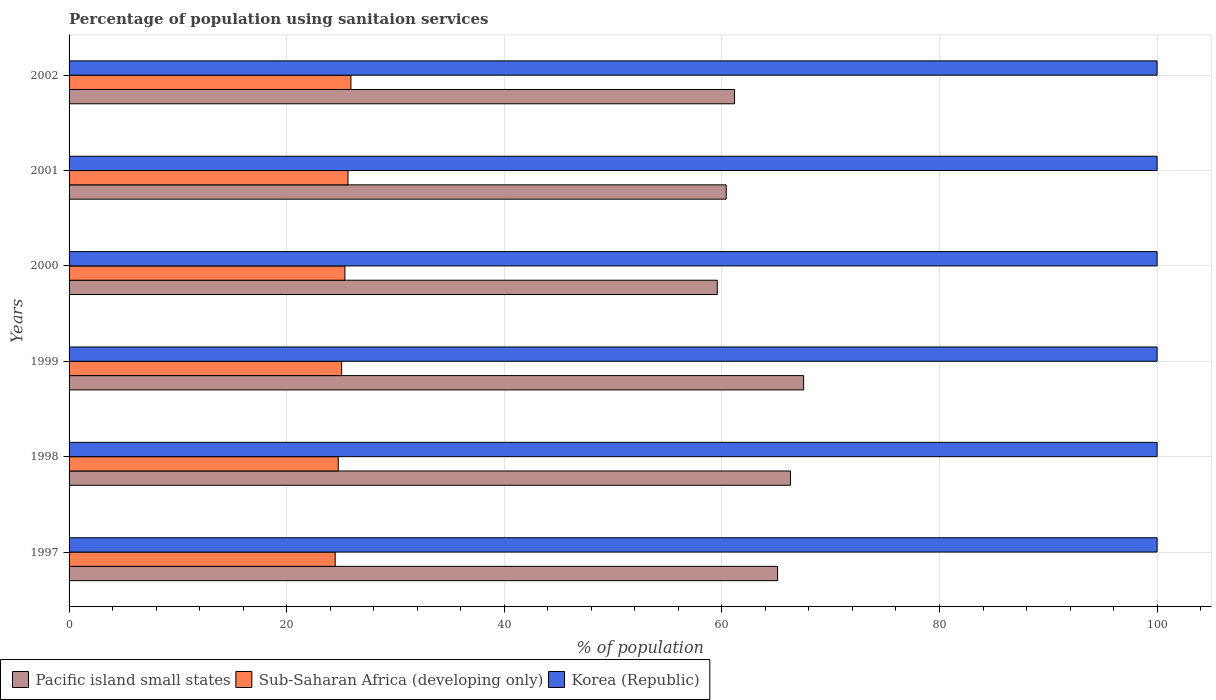How many groups of bars are there?
Ensure brevity in your answer.  6. Are the number of bars per tick equal to the number of legend labels?
Provide a succinct answer. Yes. How many bars are there on the 2nd tick from the top?
Ensure brevity in your answer.  3. How many bars are there on the 1st tick from the bottom?
Your answer should be very brief. 3. In how many cases, is the number of bars for a given year not equal to the number of legend labels?
Give a very brief answer. 0. What is the percentage of population using sanitaion services in Korea (Republic) in 1998?
Your answer should be compact. 100. Across all years, what is the maximum percentage of population using sanitaion services in Sub-Saharan Africa (developing only)?
Make the answer very short. 25.91. Across all years, what is the minimum percentage of population using sanitaion services in Pacific island small states?
Make the answer very short. 59.58. What is the total percentage of population using sanitaion services in Pacific island small states in the graph?
Provide a short and direct response. 380.07. What is the difference between the percentage of population using sanitaion services in Korea (Republic) in 1998 and that in 2000?
Offer a very short reply. 0. What is the difference between the percentage of population using sanitaion services in Sub-Saharan Africa (developing only) in 1999 and the percentage of population using sanitaion services in Korea (Republic) in 2002?
Offer a very short reply. -74.95. In the year 1998, what is the difference between the percentage of population using sanitaion services in Sub-Saharan Africa (developing only) and percentage of population using sanitaion services in Korea (Republic)?
Give a very brief answer. -75.26. What is the ratio of the percentage of population using sanitaion services in Sub-Saharan Africa (developing only) in 2001 to that in 2002?
Offer a very short reply. 0.99. Is the percentage of population using sanitaion services in Korea (Republic) in 1999 less than that in 2000?
Your response must be concise. No. What is the difference between the highest and the second highest percentage of population using sanitaion services in Sub-Saharan Africa (developing only)?
Ensure brevity in your answer.  0.27. What is the difference between the highest and the lowest percentage of population using sanitaion services in Sub-Saharan Africa (developing only)?
Give a very brief answer. 1.45. What does the 3rd bar from the bottom in 2001 represents?
Your answer should be very brief. Korea (Republic). Is it the case that in every year, the sum of the percentage of population using sanitaion services in Pacific island small states and percentage of population using sanitaion services in Korea (Republic) is greater than the percentage of population using sanitaion services in Sub-Saharan Africa (developing only)?
Give a very brief answer. Yes. How many bars are there?
Your answer should be compact. 18. Are all the bars in the graph horizontal?
Provide a succinct answer. Yes. How many years are there in the graph?
Provide a short and direct response. 6. What is the difference between two consecutive major ticks on the X-axis?
Your answer should be very brief. 20. Are the values on the major ticks of X-axis written in scientific E-notation?
Provide a short and direct response. No. Where does the legend appear in the graph?
Provide a short and direct response. Bottom left. How are the legend labels stacked?
Give a very brief answer. Horizontal. What is the title of the graph?
Your answer should be compact. Percentage of population using sanitaion services. What is the label or title of the X-axis?
Provide a succinct answer. % of population. What is the label or title of the Y-axis?
Give a very brief answer. Years. What is the % of population in Pacific island small states in 1997?
Keep it short and to the point. 65.12. What is the % of population of Sub-Saharan Africa (developing only) in 1997?
Provide a succinct answer. 24.46. What is the % of population of Pacific island small states in 1998?
Your answer should be compact. 66.3. What is the % of population in Sub-Saharan Africa (developing only) in 1998?
Offer a very short reply. 24.74. What is the % of population of Korea (Republic) in 1998?
Your answer should be compact. 100. What is the % of population in Pacific island small states in 1999?
Offer a terse response. 67.51. What is the % of population of Sub-Saharan Africa (developing only) in 1999?
Ensure brevity in your answer.  25.05. What is the % of population of Korea (Republic) in 1999?
Give a very brief answer. 100. What is the % of population of Pacific island small states in 2000?
Your answer should be compact. 59.58. What is the % of population in Sub-Saharan Africa (developing only) in 2000?
Provide a short and direct response. 25.35. What is the % of population in Pacific island small states in 2001?
Offer a terse response. 60.4. What is the % of population of Sub-Saharan Africa (developing only) in 2001?
Provide a short and direct response. 25.64. What is the % of population in Korea (Republic) in 2001?
Provide a short and direct response. 100. What is the % of population in Pacific island small states in 2002?
Give a very brief answer. 61.16. What is the % of population in Sub-Saharan Africa (developing only) in 2002?
Keep it short and to the point. 25.91. Across all years, what is the maximum % of population in Pacific island small states?
Your answer should be very brief. 67.51. Across all years, what is the maximum % of population in Sub-Saharan Africa (developing only)?
Your response must be concise. 25.91. Across all years, what is the maximum % of population of Korea (Republic)?
Make the answer very short. 100. Across all years, what is the minimum % of population in Pacific island small states?
Your answer should be compact. 59.58. Across all years, what is the minimum % of population of Sub-Saharan Africa (developing only)?
Offer a very short reply. 24.46. Across all years, what is the minimum % of population of Korea (Republic)?
Your answer should be compact. 100. What is the total % of population in Pacific island small states in the graph?
Provide a succinct answer. 380.07. What is the total % of population in Sub-Saharan Africa (developing only) in the graph?
Your answer should be compact. 151.14. What is the total % of population of Korea (Republic) in the graph?
Provide a short and direct response. 600. What is the difference between the % of population of Pacific island small states in 1997 and that in 1998?
Provide a short and direct response. -1.18. What is the difference between the % of population in Sub-Saharan Africa (developing only) in 1997 and that in 1998?
Your answer should be compact. -0.28. What is the difference between the % of population of Pacific island small states in 1997 and that in 1999?
Your answer should be compact. -2.39. What is the difference between the % of population of Sub-Saharan Africa (developing only) in 1997 and that in 1999?
Provide a succinct answer. -0.59. What is the difference between the % of population in Korea (Republic) in 1997 and that in 1999?
Your response must be concise. 0. What is the difference between the % of population of Pacific island small states in 1997 and that in 2000?
Keep it short and to the point. 5.54. What is the difference between the % of population of Sub-Saharan Africa (developing only) in 1997 and that in 2000?
Offer a very short reply. -0.89. What is the difference between the % of population in Pacific island small states in 1997 and that in 2001?
Offer a very short reply. 4.73. What is the difference between the % of population of Sub-Saharan Africa (developing only) in 1997 and that in 2001?
Your answer should be very brief. -1.18. What is the difference between the % of population in Pacific island small states in 1997 and that in 2002?
Your response must be concise. 3.96. What is the difference between the % of population in Sub-Saharan Africa (developing only) in 1997 and that in 2002?
Ensure brevity in your answer.  -1.45. What is the difference between the % of population in Pacific island small states in 1998 and that in 1999?
Provide a short and direct response. -1.21. What is the difference between the % of population in Sub-Saharan Africa (developing only) in 1998 and that in 1999?
Offer a terse response. -0.31. What is the difference between the % of population in Korea (Republic) in 1998 and that in 1999?
Give a very brief answer. 0. What is the difference between the % of population in Pacific island small states in 1998 and that in 2000?
Provide a succinct answer. 6.73. What is the difference between the % of population of Sub-Saharan Africa (developing only) in 1998 and that in 2000?
Offer a very short reply. -0.61. What is the difference between the % of population of Pacific island small states in 1998 and that in 2001?
Your answer should be very brief. 5.91. What is the difference between the % of population in Sub-Saharan Africa (developing only) in 1998 and that in 2001?
Your response must be concise. -0.9. What is the difference between the % of population in Pacific island small states in 1998 and that in 2002?
Offer a terse response. 5.14. What is the difference between the % of population in Sub-Saharan Africa (developing only) in 1998 and that in 2002?
Your answer should be very brief. -1.17. What is the difference between the % of population of Pacific island small states in 1999 and that in 2000?
Provide a short and direct response. 7.94. What is the difference between the % of population of Sub-Saharan Africa (developing only) in 1999 and that in 2000?
Offer a very short reply. -0.3. What is the difference between the % of population in Pacific island small states in 1999 and that in 2001?
Offer a very short reply. 7.12. What is the difference between the % of population in Sub-Saharan Africa (developing only) in 1999 and that in 2001?
Make the answer very short. -0.59. What is the difference between the % of population of Korea (Republic) in 1999 and that in 2001?
Your answer should be compact. 0. What is the difference between the % of population in Pacific island small states in 1999 and that in 2002?
Your answer should be very brief. 6.35. What is the difference between the % of population of Sub-Saharan Africa (developing only) in 1999 and that in 2002?
Provide a short and direct response. -0.86. What is the difference between the % of population of Pacific island small states in 2000 and that in 2001?
Ensure brevity in your answer.  -0.82. What is the difference between the % of population in Sub-Saharan Africa (developing only) in 2000 and that in 2001?
Keep it short and to the point. -0.29. What is the difference between the % of population in Pacific island small states in 2000 and that in 2002?
Your answer should be very brief. -1.59. What is the difference between the % of population in Sub-Saharan Africa (developing only) in 2000 and that in 2002?
Your answer should be very brief. -0.55. What is the difference between the % of population of Pacific island small states in 2001 and that in 2002?
Ensure brevity in your answer.  -0.77. What is the difference between the % of population of Sub-Saharan Africa (developing only) in 2001 and that in 2002?
Give a very brief answer. -0.27. What is the difference between the % of population in Pacific island small states in 1997 and the % of population in Sub-Saharan Africa (developing only) in 1998?
Keep it short and to the point. 40.38. What is the difference between the % of population in Pacific island small states in 1997 and the % of population in Korea (Republic) in 1998?
Give a very brief answer. -34.88. What is the difference between the % of population of Sub-Saharan Africa (developing only) in 1997 and the % of population of Korea (Republic) in 1998?
Give a very brief answer. -75.54. What is the difference between the % of population of Pacific island small states in 1997 and the % of population of Sub-Saharan Africa (developing only) in 1999?
Keep it short and to the point. 40.07. What is the difference between the % of population in Pacific island small states in 1997 and the % of population in Korea (Republic) in 1999?
Make the answer very short. -34.88. What is the difference between the % of population of Sub-Saharan Africa (developing only) in 1997 and the % of population of Korea (Republic) in 1999?
Your response must be concise. -75.54. What is the difference between the % of population of Pacific island small states in 1997 and the % of population of Sub-Saharan Africa (developing only) in 2000?
Make the answer very short. 39.77. What is the difference between the % of population in Pacific island small states in 1997 and the % of population in Korea (Republic) in 2000?
Provide a short and direct response. -34.88. What is the difference between the % of population of Sub-Saharan Africa (developing only) in 1997 and the % of population of Korea (Republic) in 2000?
Ensure brevity in your answer.  -75.54. What is the difference between the % of population of Pacific island small states in 1997 and the % of population of Sub-Saharan Africa (developing only) in 2001?
Offer a very short reply. 39.48. What is the difference between the % of population of Pacific island small states in 1997 and the % of population of Korea (Republic) in 2001?
Give a very brief answer. -34.88. What is the difference between the % of population in Sub-Saharan Africa (developing only) in 1997 and the % of population in Korea (Republic) in 2001?
Your answer should be very brief. -75.54. What is the difference between the % of population of Pacific island small states in 1997 and the % of population of Sub-Saharan Africa (developing only) in 2002?
Provide a succinct answer. 39.22. What is the difference between the % of population of Pacific island small states in 1997 and the % of population of Korea (Republic) in 2002?
Provide a succinct answer. -34.88. What is the difference between the % of population of Sub-Saharan Africa (developing only) in 1997 and the % of population of Korea (Republic) in 2002?
Keep it short and to the point. -75.54. What is the difference between the % of population of Pacific island small states in 1998 and the % of population of Sub-Saharan Africa (developing only) in 1999?
Your response must be concise. 41.25. What is the difference between the % of population in Pacific island small states in 1998 and the % of population in Korea (Republic) in 1999?
Keep it short and to the point. -33.7. What is the difference between the % of population of Sub-Saharan Africa (developing only) in 1998 and the % of population of Korea (Republic) in 1999?
Keep it short and to the point. -75.26. What is the difference between the % of population in Pacific island small states in 1998 and the % of population in Sub-Saharan Africa (developing only) in 2000?
Your answer should be very brief. 40.95. What is the difference between the % of population of Pacific island small states in 1998 and the % of population of Korea (Republic) in 2000?
Ensure brevity in your answer.  -33.7. What is the difference between the % of population of Sub-Saharan Africa (developing only) in 1998 and the % of population of Korea (Republic) in 2000?
Ensure brevity in your answer.  -75.26. What is the difference between the % of population of Pacific island small states in 1998 and the % of population of Sub-Saharan Africa (developing only) in 2001?
Give a very brief answer. 40.67. What is the difference between the % of population in Pacific island small states in 1998 and the % of population in Korea (Republic) in 2001?
Offer a terse response. -33.7. What is the difference between the % of population of Sub-Saharan Africa (developing only) in 1998 and the % of population of Korea (Republic) in 2001?
Make the answer very short. -75.26. What is the difference between the % of population of Pacific island small states in 1998 and the % of population of Sub-Saharan Africa (developing only) in 2002?
Provide a succinct answer. 40.4. What is the difference between the % of population in Pacific island small states in 1998 and the % of population in Korea (Republic) in 2002?
Your answer should be very brief. -33.7. What is the difference between the % of population of Sub-Saharan Africa (developing only) in 1998 and the % of population of Korea (Republic) in 2002?
Ensure brevity in your answer.  -75.26. What is the difference between the % of population in Pacific island small states in 1999 and the % of population in Sub-Saharan Africa (developing only) in 2000?
Provide a succinct answer. 42.16. What is the difference between the % of population of Pacific island small states in 1999 and the % of population of Korea (Republic) in 2000?
Provide a short and direct response. -32.49. What is the difference between the % of population of Sub-Saharan Africa (developing only) in 1999 and the % of population of Korea (Republic) in 2000?
Give a very brief answer. -74.95. What is the difference between the % of population in Pacific island small states in 1999 and the % of population in Sub-Saharan Africa (developing only) in 2001?
Give a very brief answer. 41.88. What is the difference between the % of population in Pacific island small states in 1999 and the % of population in Korea (Republic) in 2001?
Provide a short and direct response. -32.49. What is the difference between the % of population in Sub-Saharan Africa (developing only) in 1999 and the % of population in Korea (Republic) in 2001?
Provide a short and direct response. -74.95. What is the difference between the % of population in Pacific island small states in 1999 and the % of population in Sub-Saharan Africa (developing only) in 2002?
Ensure brevity in your answer.  41.61. What is the difference between the % of population in Pacific island small states in 1999 and the % of population in Korea (Republic) in 2002?
Provide a succinct answer. -32.49. What is the difference between the % of population of Sub-Saharan Africa (developing only) in 1999 and the % of population of Korea (Republic) in 2002?
Your answer should be very brief. -74.95. What is the difference between the % of population of Pacific island small states in 2000 and the % of population of Sub-Saharan Africa (developing only) in 2001?
Offer a very short reply. 33.94. What is the difference between the % of population in Pacific island small states in 2000 and the % of population in Korea (Republic) in 2001?
Ensure brevity in your answer.  -40.42. What is the difference between the % of population of Sub-Saharan Africa (developing only) in 2000 and the % of population of Korea (Republic) in 2001?
Your response must be concise. -74.65. What is the difference between the % of population of Pacific island small states in 2000 and the % of population of Sub-Saharan Africa (developing only) in 2002?
Your answer should be very brief. 33.67. What is the difference between the % of population of Pacific island small states in 2000 and the % of population of Korea (Republic) in 2002?
Provide a succinct answer. -40.42. What is the difference between the % of population of Sub-Saharan Africa (developing only) in 2000 and the % of population of Korea (Republic) in 2002?
Provide a succinct answer. -74.65. What is the difference between the % of population of Pacific island small states in 2001 and the % of population of Sub-Saharan Africa (developing only) in 2002?
Make the answer very short. 34.49. What is the difference between the % of population in Pacific island small states in 2001 and the % of population in Korea (Republic) in 2002?
Offer a terse response. -39.6. What is the difference between the % of population of Sub-Saharan Africa (developing only) in 2001 and the % of population of Korea (Republic) in 2002?
Make the answer very short. -74.36. What is the average % of population of Pacific island small states per year?
Your answer should be compact. 63.35. What is the average % of population of Sub-Saharan Africa (developing only) per year?
Give a very brief answer. 25.19. What is the average % of population of Korea (Republic) per year?
Provide a succinct answer. 100. In the year 1997, what is the difference between the % of population of Pacific island small states and % of population of Sub-Saharan Africa (developing only)?
Offer a terse response. 40.66. In the year 1997, what is the difference between the % of population in Pacific island small states and % of population in Korea (Republic)?
Your response must be concise. -34.88. In the year 1997, what is the difference between the % of population of Sub-Saharan Africa (developing only) and % of population of Korea (Republic)?
Your answer should be very brief. -75.54. In the year 1998, what is the difference between the % of population of Pacific island small states and % of population of Sub-Saharan Africa (developing only)?
Offer a terse response. 41.56. In the year 1998, what is the difference between the % of population in Pacific island small states and % of population in Korea (Republic)?
Provide a short and direct response. -33.7. In the year 1998, what is the difference between the % of population of Sub-Saharan Africa (developing only) and % of population of Korea (Republic)?
Provide a short and direct response. -75.26. In the year 1999, what is the difference between the % of population in Pacific island small states and % of population in Sub-Saharan Africa (developing only)?
Your answer should be compact. 42.46. In the year 1999, what is the difference between the % of population in Pacific island small states and % of population in Korea (Republic)?
Make the answer very short. -32.49. In the year 1999, what is the difference between the % of population in Sub-Saharan Africa (developing only) and % of population in Korea (Republic)?
Give a very brief answer. -74.95. In the year 2000, what is the difference between the % of population in Pacific island small states and % of population in Sub-Saharan Africa (developing only)?
Keep it short and to the point. 34.23. In the year 2000, what is the difference between the % of population of Pacific island small states and % of population of Korea (Republic)?
Provide a short and direct response. -40.42. In the year 2000, what is the difference between the % of population of Sub-Saharan Africa (developing only) and % of population of Korea (Republic)?
Your answer should be very brief. -74.65. In the year 2001, what is the difference between the % of population in Pacific island small states and % of population in Sub-Saharan Africa (developing only)?
Provide a short and direct response. 34.76. In the year 2001, what is the difference between the % of population of Pacific island small states and % of population of Korea (Republic)?
Keep it short and to the point. -39.6. In the year 2001, what is the difference between the % of population in Sub-Saharan Africa (developing only) and % of population in Korea (Republic)?
Make the answer very short. -74.36. In the year 2002, what is the difference between the % of population of Pacific island small states and % of population of Sub-Saharan Africa (developing only)?
Make the answer very short. 35.26. In the year 2002, what is the difference between the % of population of Pacific island small states and % of population of Korea (Republic)?
Ensure brevity in your answer.  -38.84. In the year 2002, what is the difference between the % of population of Sub-Saharan Africa (developing only) and % of population of Korea (Republic)?
Your answer should be very brief. -74.09. What is the ratio of the % of population of Pacific island small states in 1997 to that in 1998?
Give a very brief answer. 0.98. What is the ratio of the % of population in Korea (Republic) in 1997 to that in 1998?
Offer a terse response. 1. What is the ratio of the % of population of Pacific island small states in 1997 to that in 1999?
Keep it short and to the point. 0.96. What is the ratio of the % of population in Sub-Saharan Africa (developing only) in 1997 to that in 1999?
Your answer should be very brief. 0.98. What is the ratio of the % of population in Pacific island small states in 1997 to that in 2000?
Make the answer very short. 1.09. What is the ratio of the % of population of Sub-Saharan Africa (developing only) in 1997 to that in 2000?
Keep it short and to the point. 0.96. What is the ratio of the % of population of Korea (Republic) in 1997 to that in 2000?
Your answer should be very brief. 1. What is the ratio of the % of population of Pacific island small states in 1997 to that in 2001?
Make the answer very short. 1.08. What is the ratio of the % of population of Sub-Saharan Africa (developing only) in 1997 to that in 2001?
Provide a succinct answer. 0.95. What is the ratio of the % of population of Korea (Republic) in 1997 to that in 2001?
Offer a terse response. 1. What is the ratio of the % of population of Pacific island small states in 1997 to that in 2002?
Keep it short and to the point. 1.06. What is the ratio of the % of population in Sub-Saharan Africa (developing only) in 1997 to that in 2002?
Make the answer very short. 0.94. What is the ratio of the % of population of Pacific island small states in 1998 to that in 1999?
Your answer should be compact. 0.98. What is the ratio of the % of population in Sub-Saharan Africa (developing only) in 1998 to that in 1999?
Offer a very short reply. 0.99. What is the ratio of the % of population in Pacific island small states in 1998 to that in 2000?
Your answer should be very brief. 1.11. What is the ratio of the % of population of Sub-Saharan Africa (developing only) in 1998 to that in 2000?
Your answer should be compact. 0.98. What is the ratio of the % of population in Korea (Republic) in 1998 to that in 2000?
Ensure brevity in your answer.  1. What is the ratio of the % of population in Pacific island small states in 1998 to that in 2001?
Your response must be concise. 1.1. What is the ratio of the % of population of Sub-Saharan Africa (developing only) in 1998 to that in 2001?
Keep it short and to the point. 0.96. What is the ratio of the % of population of Pacific island small states in 1998 to that in 2002?
Provide a short and direct response. 1.08. What is the ratio of the % of population in Sub-Saharan Africa (developing only) in 1998 to that in 2002?
Make the answer very short. 0.95. What is the ratio of the % of population of Pacific island small states in 1999 to that in 2000?
Offer a terse response. 1.13. What is the ratio of the % of population in Korea (Republic) in 1999 to that in 2000?
Provide a short and direct response. 1. What is the ratio of the % of population in Pacific island small states in 1999 to that in 2001?
Offer a very short reply. 1.12. What is the ratio of the % of population in Sub-Saharan Africa (developing only) in 1999 to that in 2001?
Your response must be concise. 0.98. What is the ratio of the % of population of Korea (Republic) in 1999 to that in 2001?
Offer a terse response. 1. What is the ratio of the % of population in Pacific island small states in 1999 to that in 2002?
Offer a very short reply. 1.1. What is the ratio of the % of population of Pacific island small states in 2000 to that in 2001?
Provide a short and direct response. 0.99. What is the ratio of the % of population of Sub-Saharan Africa (developing only) in 2000 to that in 2001?
Your answer should be very brief. 0.99. What is the ratio of the % of population of Pacific island small states in 2000 to that in 2002?
Provide a short and direct response. 0.97. What is the ratio of the % of population of Sub-Saharan Africa (developing only) in 2000 to that in 2002?
Make the answer very short. 0.98. What is the ratio of the % of population of Pacific island small states in 2001 to that in 2002?
Provide a short and direct response. 0.99. What is the difference between the highest and the second highest % of population of Pacific island small states?
Provide a succinct answer. 1.21. What is the difference between the highest and the second highest % of population of Sub-Saharan Africa (developing only)?
Give a very brief answer. 0.27. What is the difference between the highest and the lowest % of population of Pacific island small states?
Ensure brevity in your answer.  7.94. What is the difference between the highest and the lowest % of population in Sub-Saharan Africa (developing only)?
Provide a succinct answer. 1.45. What is the difference between the highest and the lowest % of population in Korea (Republic)?
Give a very brief answer. 0. 